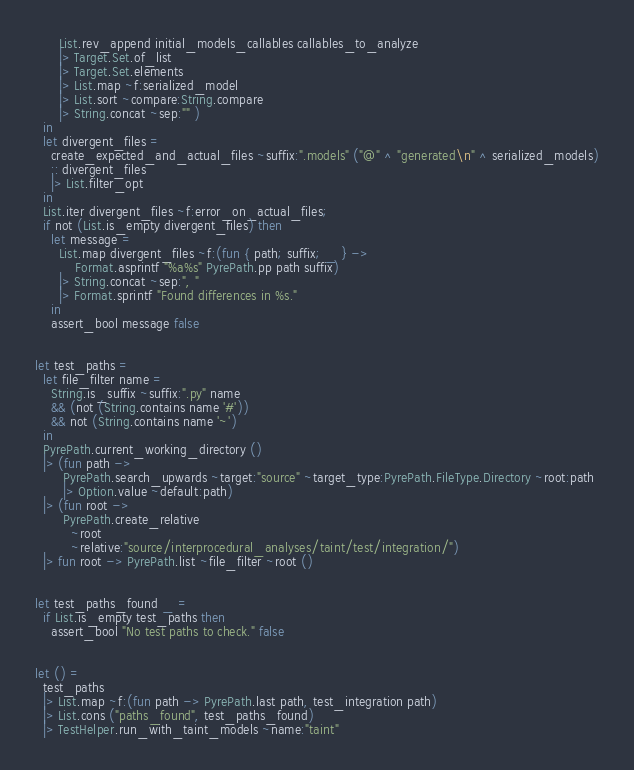Convert code to text. <code><loc_0><loc_0><loc_500><loc_500><_OCaml_>      List.rev_append initial_models_callables callables_to_analyze
      |> Target.Set.of_list
      |> Target.Set.elements
      |> List.map ~f:serialized_model
      |> List.sort ~compare:String.compare
      |> String.concat ~sep:"" )
  in
  let divergent_files =
    create_expected_and_actual_files ~suffix:".models" ("@" ^ "generated\n" ^ serialized_models)
    :: divergent_files
    |> List.filter_opt
  in
  List.iter divergent_files ~f:error_on_actual_files;
  if not (List.is_empty divergent_files) then
    let message =
      List.map divergent_files ~f:(fun { path; suffix; _ } ->
          Format.asprintf "%a%s" PyrePath.pp path suffix)
      |> String.concat ~sep:", "
      |> Format.sprintf "Found differences in %s."
    in
    assert_bool message false


let test_paths =
  let file_filter name =
    String.is_suffix ~suffix:".py" name
    && (not (String.contains name '#'))
    && not (String.contains name '~')
  in
  PyrePath.current_working_directory ()
  |> (fun path ->
       PyrePath.search_upwards ~target:"source" ~target_type:PyrePath.FileType.Directory ~root:path
       |> Option.value ~default:path)
  |> (fun root ->
       PyrePath.create_relative
         ~root
         ~relative:"source/interprocedural_analyses/taint/test/integration/")
  |> fun root -> PyrePath.list ~file_filter ~root ()


let test_paths_found _ =
  if List.is_empty test_paths then
    assert_bool "No test paths to check." false


let () =
  test_paths
  |> List.map ~f:(fun path -> PyrePath.last path, test_integration path)
  |> List.cons ("paths_found", test_paths_found)
  |> TestHelper.run_with_taint_models ~name:"taint"
</code> 